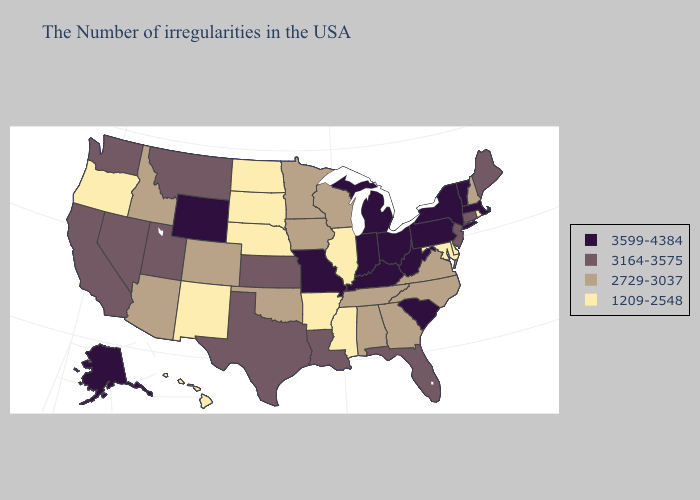Among the states that border Wisconsin , does Michigan have the highest value?
Keep it brief. Yes. Does Arizona have the lowest value in the USA?
Write a very short answer. No. What is the lowest value in the South?
Concise answer only. 1209-2548. What is the value of Tennessee?
Concise answer only. 2729-3037. Name the states that have a value in the range 3599-4384?
Concise answer only. Massachusetts, Vermont, New York, Pennsylvania, South Carolina, West Virginia, Ohio, Michigan, Kentucky, Indiana, Missouri, Wyoming, Alaska. Name the states that have a value in the range 3164-3575?
Concise answer only. Maine, Connecticut, New Jersey, Florida, Louisiana, Kansas, Texas, Utah, Montana, Nevada, California, Washington. Among the states that border Mississippi , does Louisiana have the highest value?
Short answer required. Yes. Is the legend a continuous bar?
Short answer required. No. Name the states that have a value in the range 3164-3575?
Quick response, please. Maine, Connecticut, New Jersey, Florida, Louisiana, Kansas, Texas, Utah, Montana, Nevada, California, Washington. Name the states that have a value in the range 3164-3575?
Write a very short answer. Maine, Connecticut, New Jersey, Florida, Louisiana, Kansas, Texas, Utah, Montana, Nevada, California, Washington. Does the map have missing data?
Quick response, please. No. What is the lowest value in states that border South Dakota?
Be succinct. 1209-2548. Does Colorado have the same value as Wisconsin?
Short answer required. Yes. Among the states that border Delaware , which have the lowest value?
Short answer required. Maryland. What is the value of Maryland?
Concise answer only. 1209-2548. 